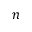<formula> <loc_0><loc_0><loc_500><loc_500>n</formula> 